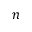<formula> <loc_0><loc_0><loc_500><loc_500>n</formula> 